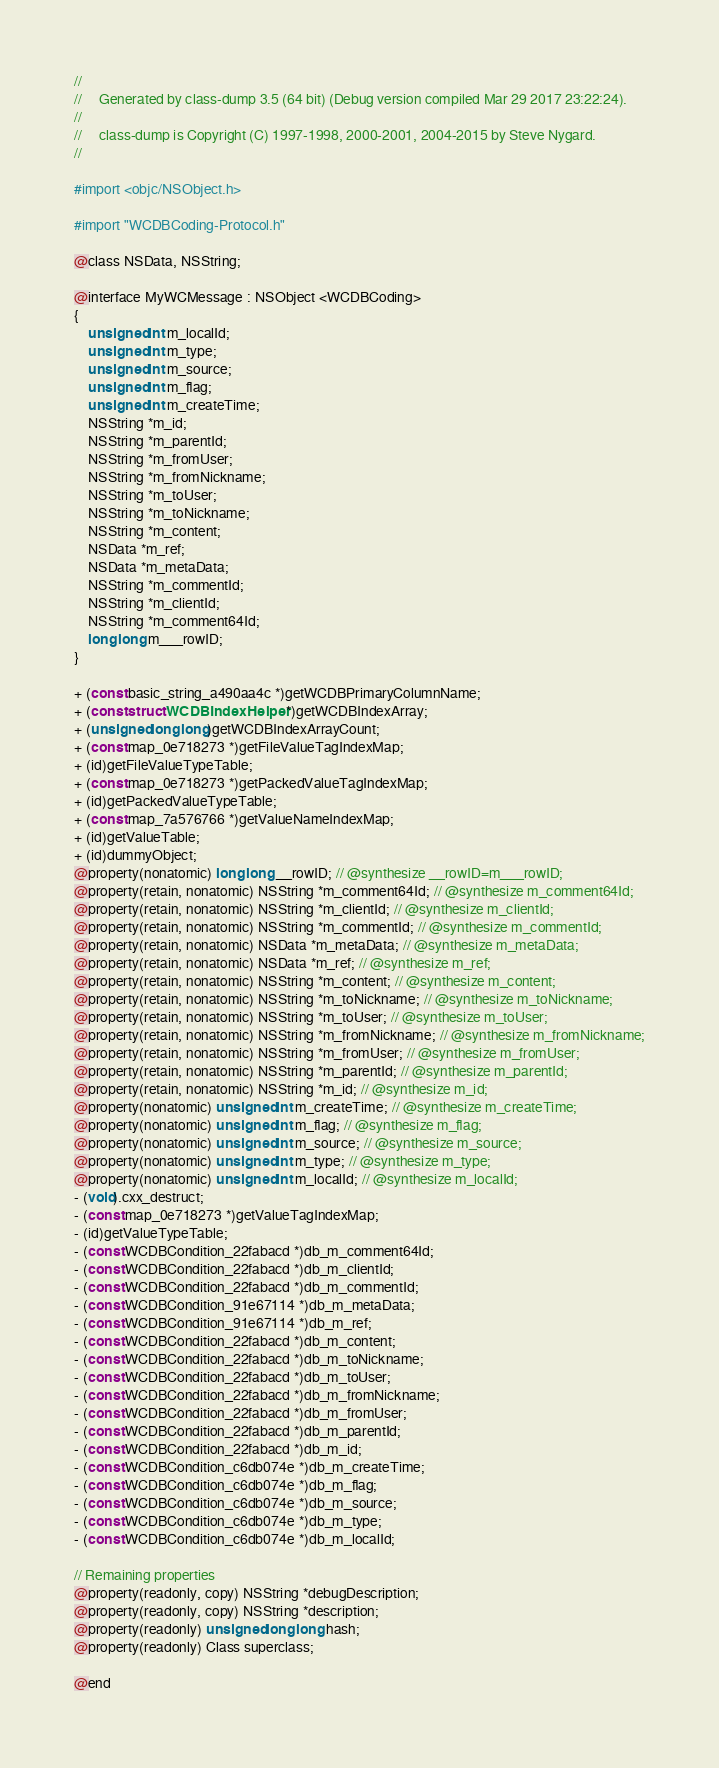Convert code to text. <code><loc_0><loc_0><loc_500><loc_500><_C_>//
//     Generated by class-dump 3.5 (64 bit) (Debug version compiled Mar 29 2017 23:22:24).
//
//     class-dump is Copyright (C) 1997-1998, 2000-2001, 2004-2015 by Steve Nygard.
//

#import <objc/NSObject.h>

#import "WCDBCoding-Protocol.h"

@class NSData, NSString;

@interface MyWCMessage : NSObject <WCDBCoding>
{
    unsigned int m_localId;
    unsigned int m_type;
    unsigned int m_source;
    unsigned int m_flag;
    unsigned int m_createTime;
    NSString *m_id;
    NSString *m_parentId;
    NSString *m_fromUser;
    NSString *m_fromNickname;
    NSString *m_toUser;
    NSString *m_toNickname;
    NSString *m_content;
    NSData *m_ref;
    NSData *m_metaData;
    NSString *m_commentId;
    NSString *m_clientId;
    NSString *m_comment64Id;
    long long m___rowID;
}

+ (const basic_string_a490aa4c *)getWCDBPrimaryColumnName;
+ (const struct WCDBIndexHelper *)getWCDBIndexArray;
+ (unsigned long long)getWCDBIndexArrayCount;
+ (const map_0e718273 *)getFileValueTagIndexMap;
+ (id)getFileValueTypeTable;
+ (const map_0e718273 *)getPackedValueTagIndexMap;
+ (id)getPackedValueTypeTable;
+ (const map_7a576766 *)getValueNameIndexMap;
+ (id)getValueTable;
+ (id)dummyObject;
@property(nonatomic) long long __rowID; // @synthesize __rowID=m___rowID;
@property(retain, nonatomic) NSString *m_comment64Id; // @synthesize m_comment64Id;
@property(retain, nonatomic) NSString *m_clientId; // @synthesize m_clientId;
@property(retain, nonatomic) NSString *m_commentId; // @synthesize m_commentId;
@property(retain, nonatomic) NSData *m_metaData; // @synthesize m_metaData;
@property(retain, nonatomic) NSData *m_ref; // @synthesize m_ref;
@property(retain, nonatomic) NSString *m_content; // @synthesize m_content;
@property(retain, nonatomic) NSString *m_toNickname; // @synthesize m_toNickname;
@property(retain, nonatomic) NSString *m_toUser; // @synthesize m_toUser;
@property(retain, nonatomic) NSString *m_fromNickname; // @synthesize m_fromNickname;
@property(retain, nonatomic) NSString *m_fromUser; // @synthesize m_fromUser;
@property(retain, nonatomic) NSString *m_parentId; // @synthesize m_parentId;
@property(retain, nonatomic) NSString *m_id; // @synthesize m_id;
@property(nonatomic) unsigned int m_createTime; // @synthesize m_createTime;
@property(nonatomic) unsigned int m_flag; // @synthesize m_flag;
@property(nonatomic) unsigned int m_source; // @synthesize m_source;
@property(nonatomic) unsigned int m_type; // @synthesize m_type;
@property(nonatomic) unsigned int m_localId; // @synthesize m_localId;
- (void).cxx_destruct;
- (const map_0e718273 *)getValueTagIndexMap;
- (id)getValueTypeTable;
- (const WCDBCondition_22fabacd *)db_m_comment64Id;
- (const WCDBCondition_22fabacd *)db_m_clientId;
- (const WCDBCondition_22fabacd *)db_m_commentId;
- (const WCDBCondition_91e67114 *)db_m_metaData;
- (const WCDBCondition_91e67114 *)db_m_ref;
- (const WCDBCondition_22fabacd *)db_m_content;
- (const WCDBCondition_22fabacd *)db_m_toNickname;
- (const WCDBCondition_22fabacd *)db_m_toUser;
- (const WCDBCondition_22fabacd *)db_m_fromNickname;
- (const WCDBCondition_22fabacd *)db_m_fromUser;
- (const WCDBCondition_22fabacd *)db_m_parentId;
- (const WCDBCondition_22fabacd *)db_m_id;
- (const WCDBCondition_c6db074e *)db_m_createTime;
- (const WCDBCondition_c6db074e *)db_m_flag;
- (const WCDBCondition_c6db074e *)db_m_source;
- (const WCDBCondition_c6db074e *)db_m_type;
- (const WCDBCondition_c6db074e *)db_m_localId;

// Remaining properties
@property(readonly, copy) NSString *debugDescription;
@property(readonly, copy) NSString *description;
@property(readonly) unsigned long long hash;
@property(readonly) Class superclass;

@end

</code> 